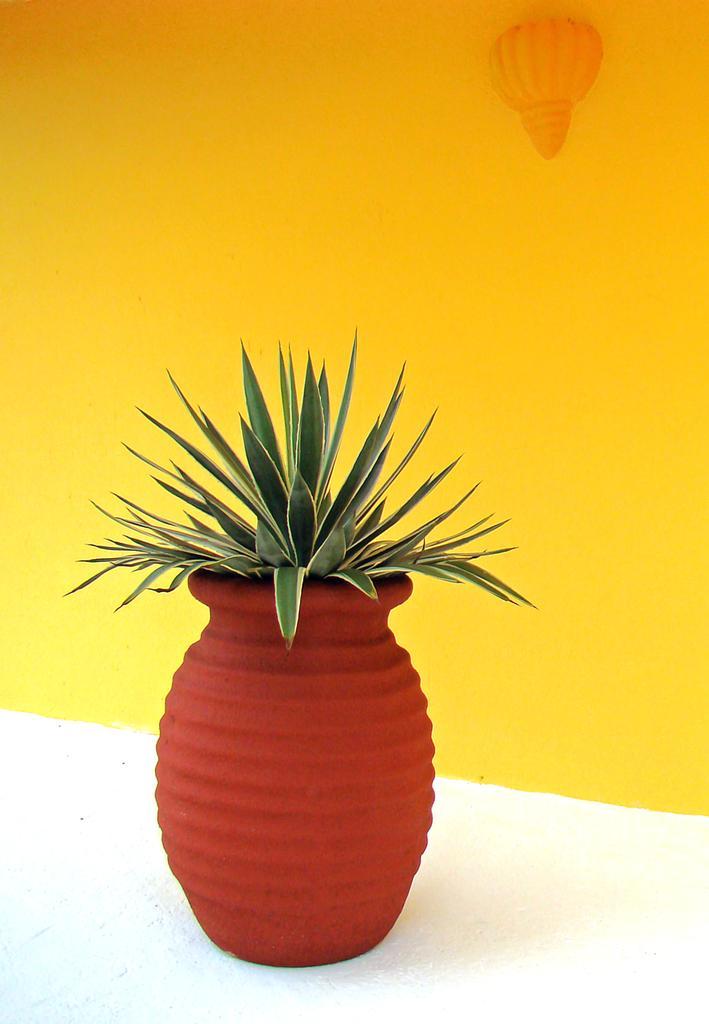Describe this image in one or two sentences. In the image we can see there is a pot in which there is a plant and behind there is a wall which is in yellow colour. 